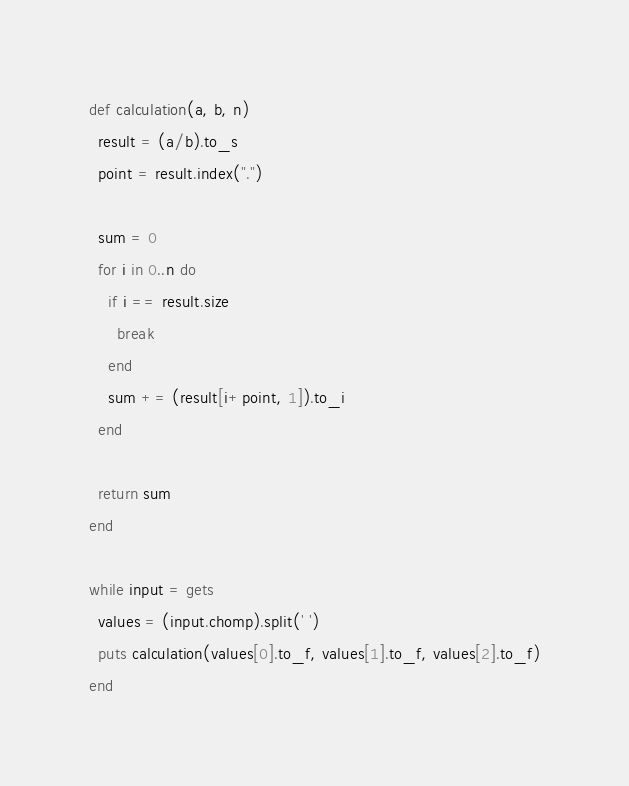<code> <loc_0><loc_0><loc_500><loc_500><_Ruby_>def calculation(a, b, n)
  result = (a/b).to_s
  point = result.index(".")

  sum = 0
  for i in 0..n do
    if i == result.size
      break
    end
    sum += (result[i+point, 1]).to_i
  end
  
  return sum
end

while input = gets
  values = (input.chomp).split(' ')
  puts calculation(values[0].to_f, values[1].to_f, values[2].to_f)
end</code> 